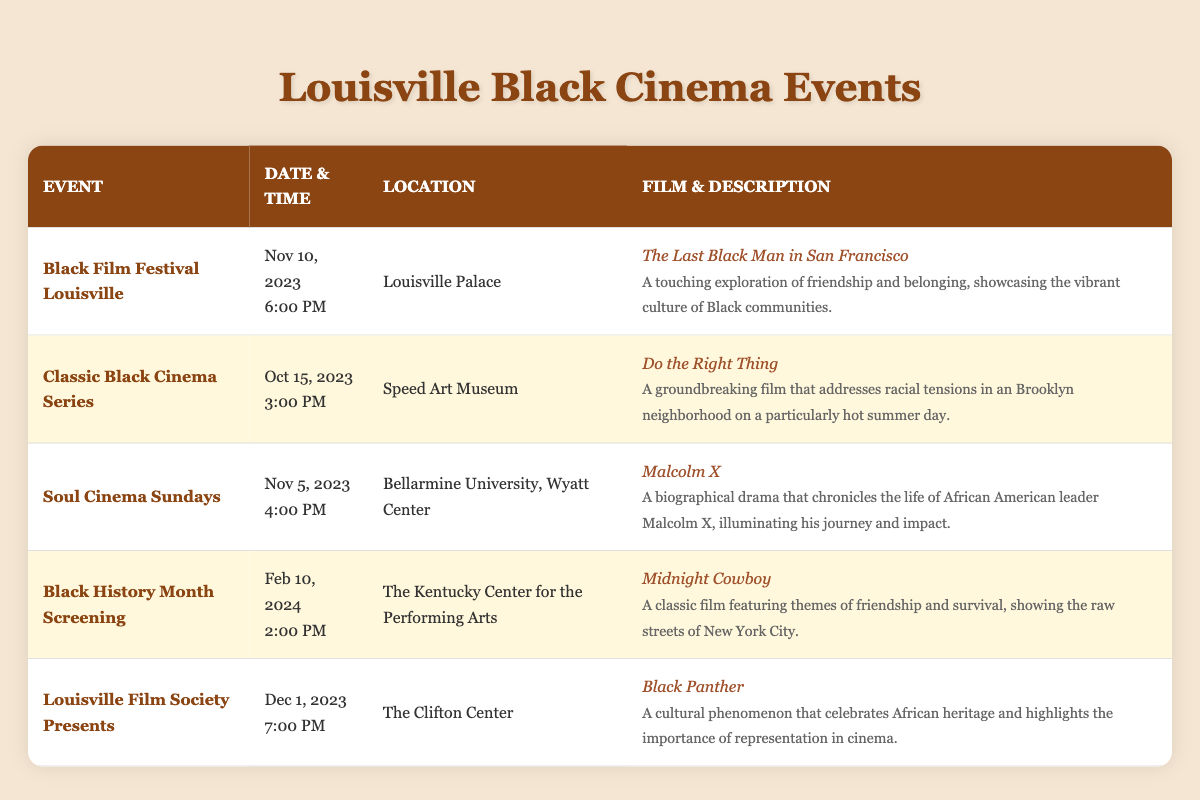What is the title of the film being screened at the Black Film Festival Louisville? The Black Film Festival Louisville is scheduled for November 10, 2023, at 6:00 PM and features "The Last Black Man in San Francisco" as the film title.
Answer: The Last Black Man in San Francisco On what date is the screening of "Malcolm X" scheduled? "Malcolm X" is scheduled to be screened during the Soul Cinema Sundays event on November 5, 2023.
Answer: November 5, 2023 How many events are screening films in November? The events scheduled in November are: 1) Soul Cinema Sundays on November 5; 2) Black Film Festival Louisville on November 10. Therefore, there are 2 events in November.
Answer: 2 Is "Do the Right Thing" being screened at the Louisville Palace? "Do the Right Thing" is scheduled for October 15, 2023, at the Speed Art Museum, not at the Louisville Palace. Therefore, the statement is false.
Answer: No Which film has a screening date closest to the end of the year? The various events listed are: 1) on November 5, 2) November 10, 3) December 1, and 4) February 10. The screening on December 1, 2023, is the closest to the end of the year.
Answer: December 1, 2023 What is the difference in days between the screening of "Black Panther" and "Midnight Cowboy"? "Black Panther" is scheduled for December 1, 2023, and "Midnight Cowboy" for February 10, 2024. The difference between these dates is 71 days, because there are 31 days in December and 10 days in February, plus the 1 day of December. Counting 30 days in November gives us an overall 10 + 31 + 30 = 71 days.
Answer: 71 days Where will the Classic Black Cinema Series take place? The Classic Black Cinema Series event is hosted at the Speed Art Museum according to the table.
Answer: Speed Art Museum Does the table show an event taking place in February? Yes, the table lists the "Black History Month Screening" event on February 10, 2024, confirming that there is an event scheduled in February.
Answer: Yes How many events have "black" in their titles? The events with "black" in their titles are: 1) Black Film Festival Louisville, 2) Black Panther (part of Louisville Film Society Presents), and 3) Black History Month Screening. This makes a total of 3 events.
Answer: 3 